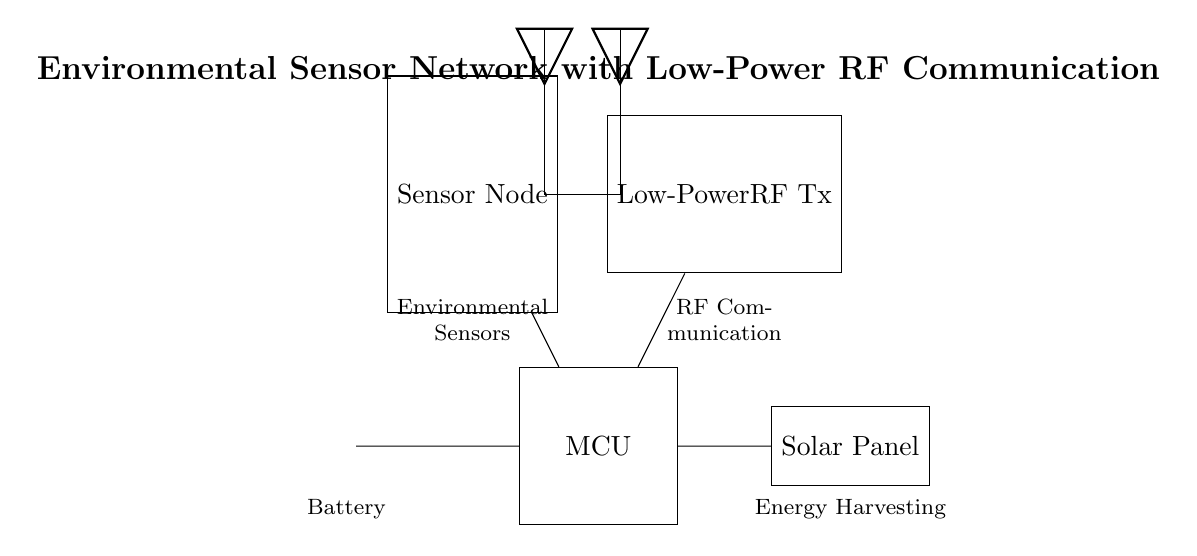What components are present in the circuit diagram? The components listed in the diagram include a sensor node, low-power RF transmitter, microcontroller, battery, and solar panel. Each of these components is clearly depicted within the circuit layout.
Answer: sensor node, low-power RF transmitter, microcontroller, battery, solar panel What is the function of the solar panel in this circuit? The solar panel functions as an energy harvesting component, providing power to the microcontroller and other connected components. Its specific role is to convert solar energy into electrical energy to support the entire system’s operation.
Answer: energy harvesting How is the microcontroller connected to other components? The microcontroller has connections to the sensor node, low-power RF transmitter, battery, and solar panel. These connections facilitate communication and power supply among all components in the circuit.
Answer: four connections What type of communication does the transmitter use? The transmitter is labeled as a low-power RF transmitter, indicating that it utilizes radio frequency communication for transmitting data from the sensor node to other components or receivers.
Answer: radio frequency Why is a low-power RF transmitter chosen for this environmental sensor network? A low-power RF transmitter is ideal for an environmental sensor network because it requires less energy, making it suitable for battery-operated or solar-powered applications. This is crucial in remote areas where power sources may be limited, ensuring prolonged functionality of the sensor system.
Answer: energy efficiency What is the purpose of battery in the circuit? The battery serves as the primary power source for the microcontroller and the other components during periods when solar energy is insufficient, ensuring continual operation of the sensor network.
Answer: primary power source What can be inferred about the flexibility of this circuit in different environments? The inclusion of energy harvesting from a solar panel and a low-power RF transmitter suggests that the circuit is designed for versatility, capable of functioning effectively in various environmental conditions while minimizing ecological impact.
Answer: environmental adaptability 